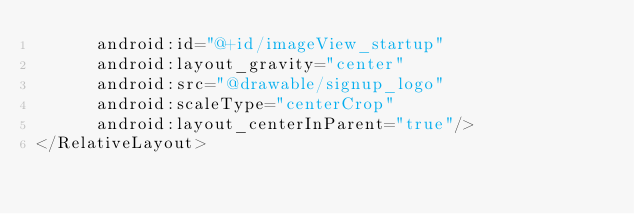<code> <loc_0><loc_0><loc_500><loc_500><_XML_>      android:id="@+id/imageView_startup"
      android:layout_gravity="center"
      android:src="@drawable/signup_logo"
      android:scaleType="centerCrop"
      android:layout_centerInParent="true"/>
</RelativeLayout>
</code> 